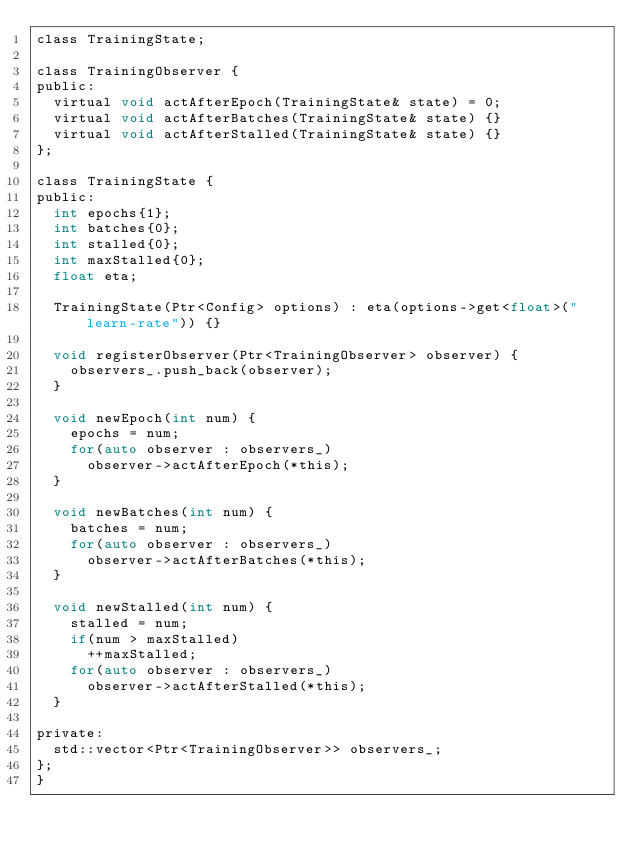Convert code to text. <code><loc_0><loc_0><loc_500><loc_500><_C_>class TrainingState;

class TrainingObserver {
public:
  virtual void actAfterEpoch(TrainingState& state) = 0;
  virtual void actAfterBatches(TrainingState& state) {}
  virtual void actAfterStalled(TrainingState& state) {}
};

class TrainingState {
public:
  int epochs{1};
  int batches{0};
  int stalled{0};
  int maxStalled{0};
  float eta;

  TrainingState(Ptr<Config> options) : eta(options->get<float>("learn-rate")) {}

  void registerObserver(Ptr<TrainingObserver> observer) {
    observers_.push_back(observer);
  }

  void newEpoch(int num) {
    epochs = num;
    for(auto observer : observers_)
      observer->actAfterEpoch(*this);
  }

  void newBatches(int num) {
    batches = num;
    for(auto observer : observers_)
      observer->actAfterBatches(*this);
  }

  void newStalled(int num) {
    stalled = num;
    if(num > maxStalled)
      ++maxStalled;
    for(auto observer : observers_)
      observer->actAfterStalled(*this);
  }

private:
  std::vector<Ptr<TrainingObserver>> observers_;
};
}
</code> 